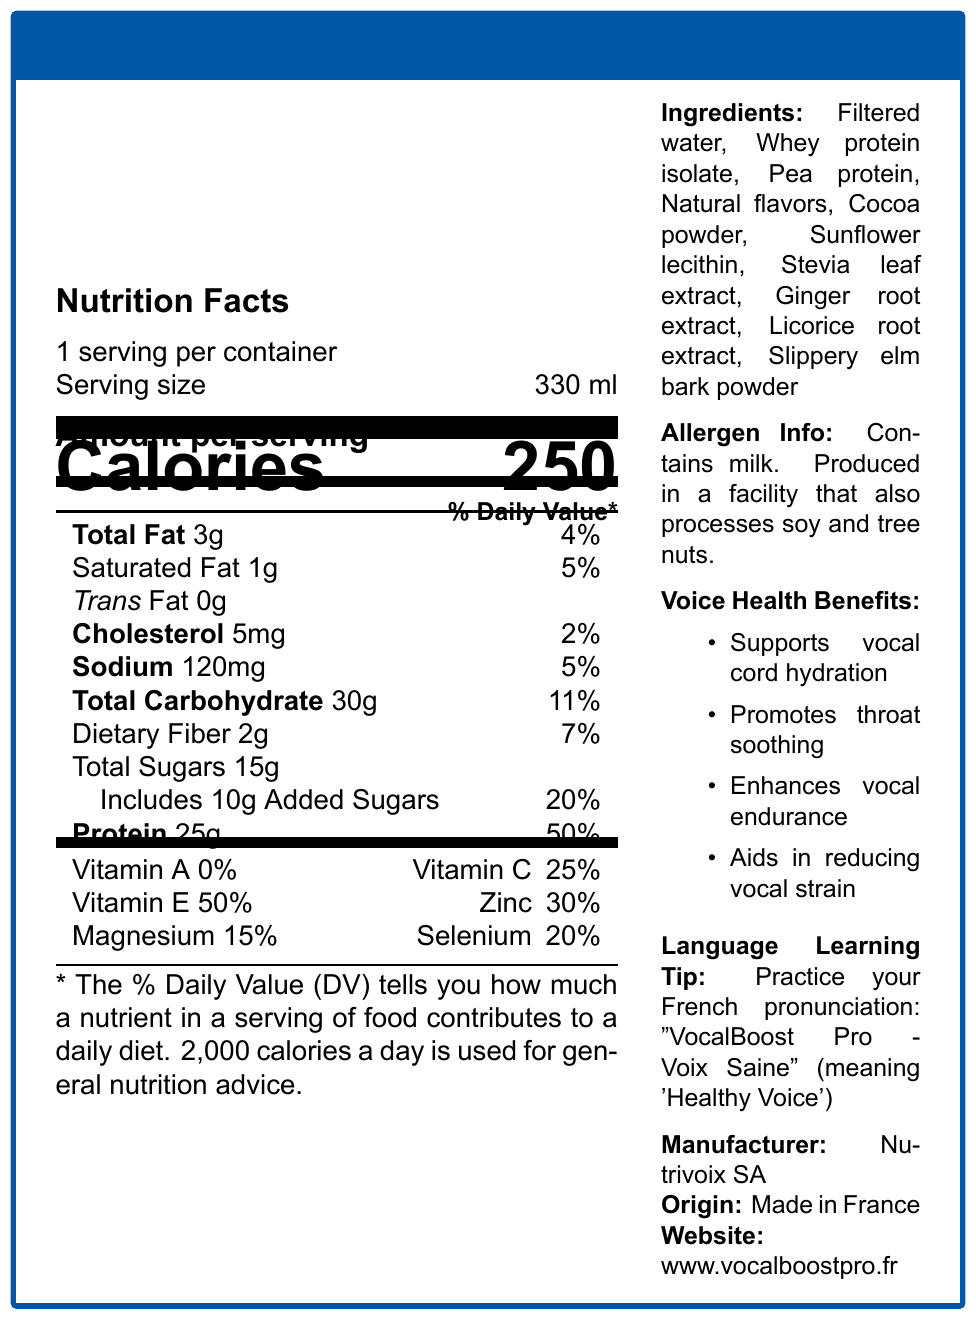What is the serving size of VocalBoost Pro - Voix Saine? The serving size is listed as 330 ml in the nutrition facts section.
Answer: 330 ml How many calories are in one serving of VocalBoost Pro - Voix Saine? The nutrition facts indicate that there are 250 calories per serving.
Answer: 250 calories What percentage of the Daily Value is the protein content? The protein content is listed as 25g, which corresponds to 50% of the Daily Value.
Answer: 50% What is the amount of added sugars in the product? The added sugars are listed as 10g in the nutrition facts.
Answer: 10g What is the manufacturer's name? The manufacturer's name is listed as Nutrivoix SA at the bottom of the document.
Answer: Nutrivoix SA Does this product contain any milk? The allergen information states that the product contains milk.
Answer: Yes Which ingredient is not listed? A. Whey protein isolate B. Pea protein C. Sugar D. Licorice root extract Sugar is not listed as an ingredient; however, Stevia leaf extract and added sugars are mentioned.
Answer: C Which of the following is NOT a health benefit mentioned for VocalBoost Pro - Voix Saine? A. Supports vocal cord hydration B. Aids in weight loss C. Enhances vocal endurance D. Promotes throat soothing "Aids in weight loss" is not listed as one of the voice health benefits.
Answer: B Does the product contain any trans fat? The nutrition facts indicate that there is 0g of trans fat in the product.
Answer: No Summarize the key features and information presented in the document. The document provides a comprehensive overview of the product by detailing its nutritional content, ingredients, benefits for voice health, allergen information, and additional context about its origin and manufacturer.
Answer: VocalBoost Pro - Voix Saine is a protein shake designed for voice health. It has 250 calories per 330 ml serving, with significant amounts of protein (25g, 50% DV), vitamins, and minerals beneficial for vocal health. It includes ingredients like whey protein isolate and licorice root extract and is manufactured by Nutrivoix SA in France. The product supports vocal cord hydration, throat soothing, and vocal endurance while cautioning for milk allergens. Additionally, its French name promotes language learning. How much sodium does the product contain? The sodium content is listed as 120mg in the nutrition facts.
Answer: 120mg What is the amount of dietary fiber in the product? The dietary fiber content is stated to be 2g in the nutrition facts.
Answer: 2g How many servings are in one container of VocalBoost Pro - Voix Saine? The document states that there is one serving per container.
Answer: 1 Which vitamins have a Daily Value percentage mentioned in the document? A. Vitamin A B. Vitamin C C. Vitamin B12 D. Vitamin D Vitamin C has a 25% Daily Value percentage listed in the nutrition facts.
Answer: B What is the main purpose of including ginger root extract in the ingredients? The document lists ginger root extract as one of the ingredients but does not specify its purpose.
Answer: Not enough information 